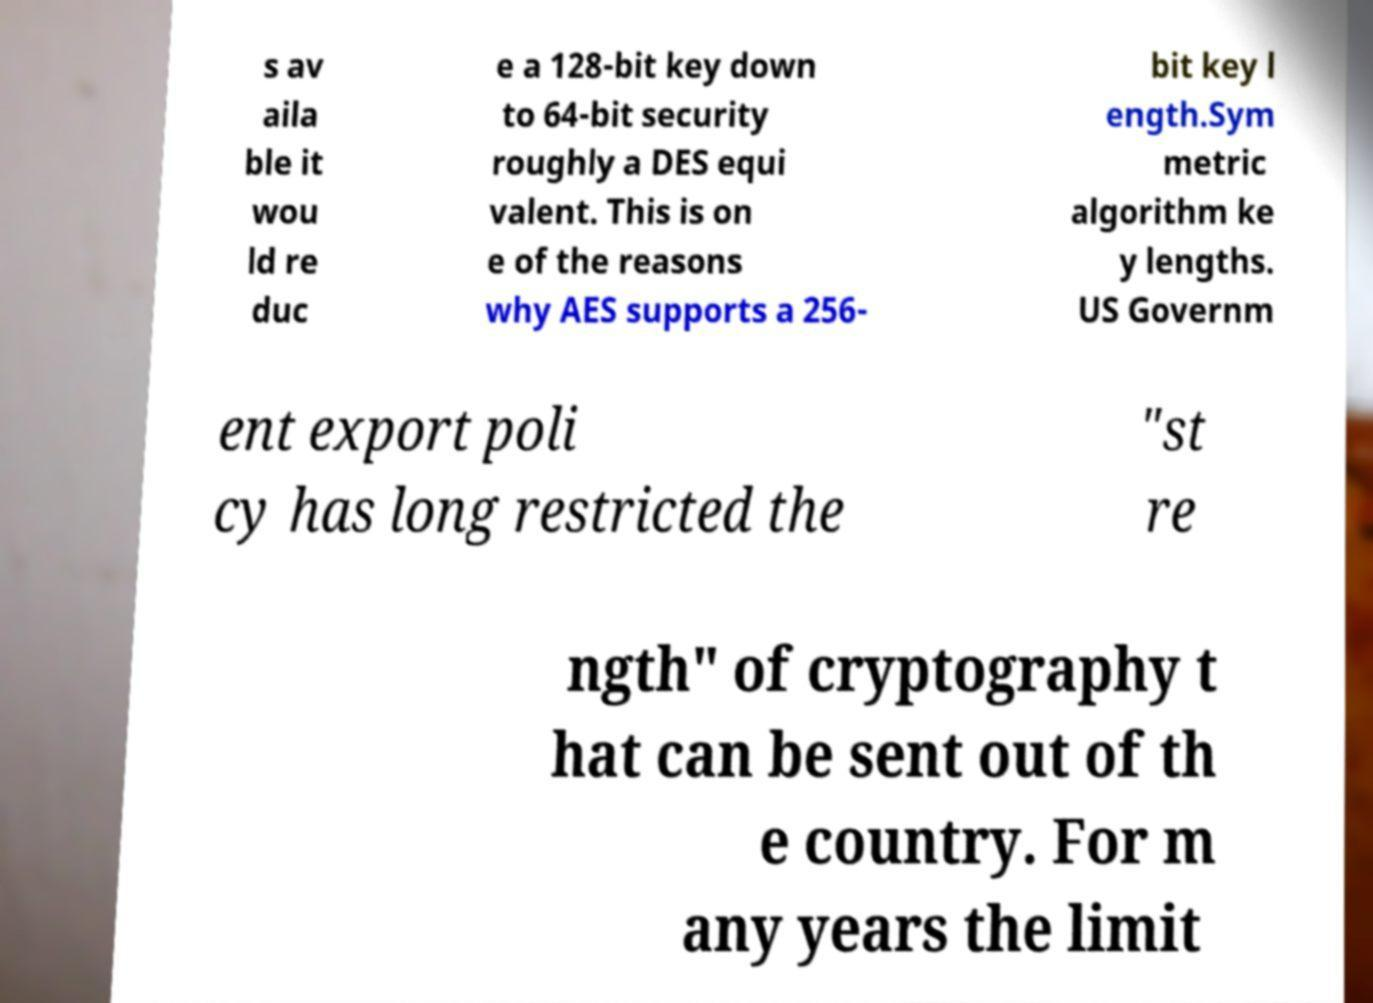Could you assist in decoding the text presented in this image and type it out clearly? s av aila ble it wou ld re duc e a 128-bit key down to 64-bit security roughly a DES equi valent. This is on e of the reasons why AES supports a 256- bit key l ength.Sym metric algorithm ke y lengths. US Governm ent export poli cy has long restricted the "st re ngth" of cryptography t hat can be sent out of th e country. For m any years the limit 